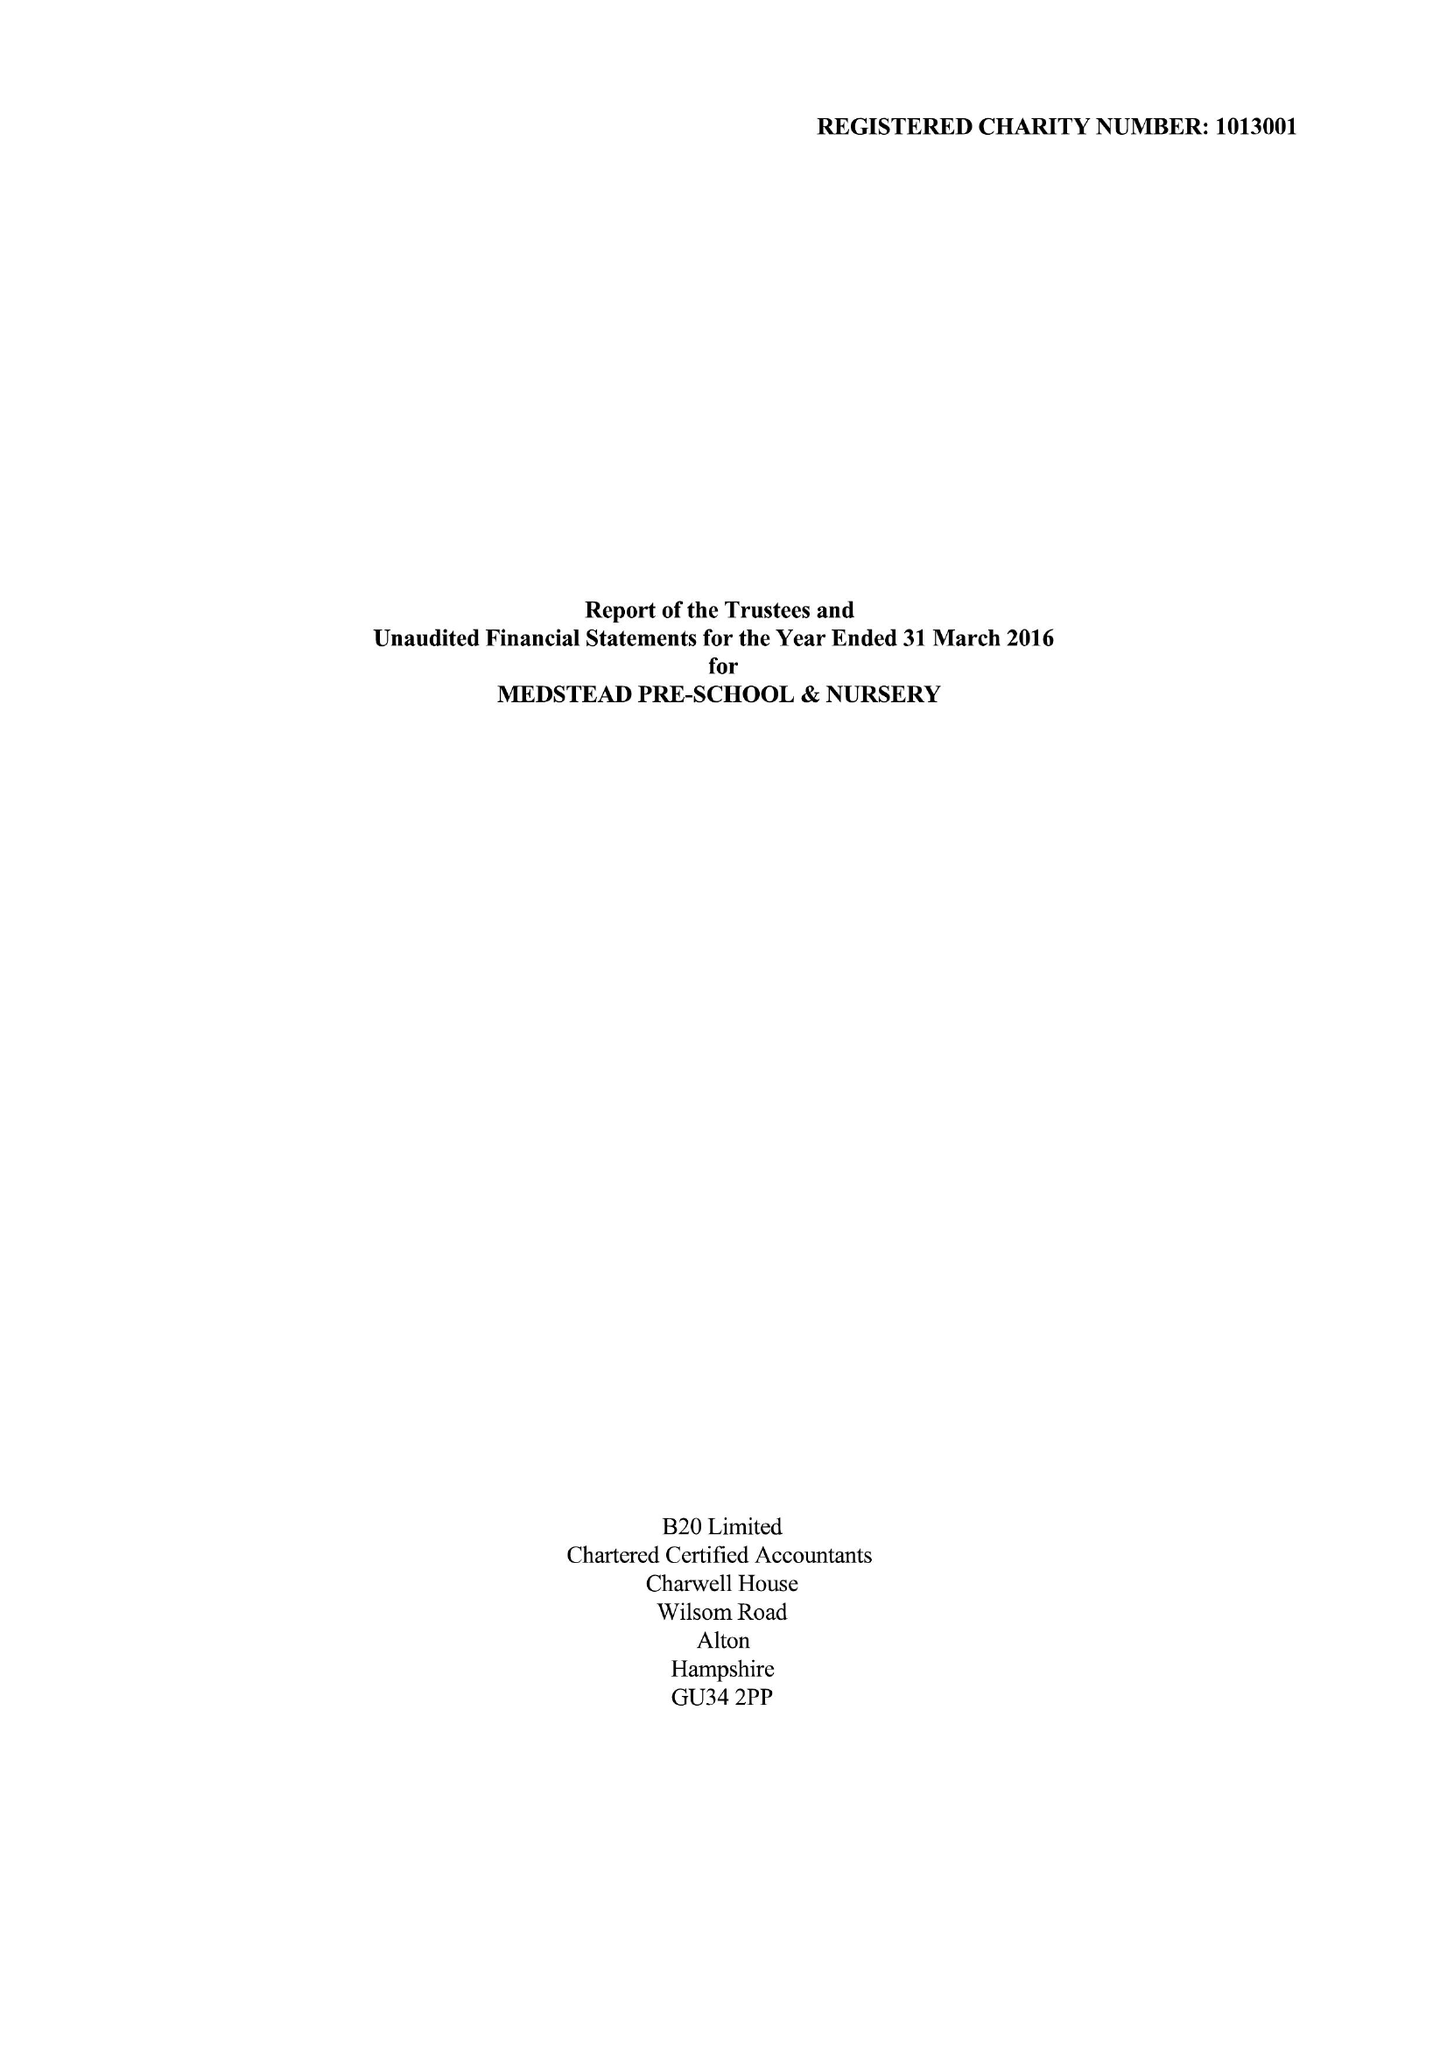What is the value for the address__street_line?
Answer the question using a single word or phrase. ROE DOWNS ROAD 